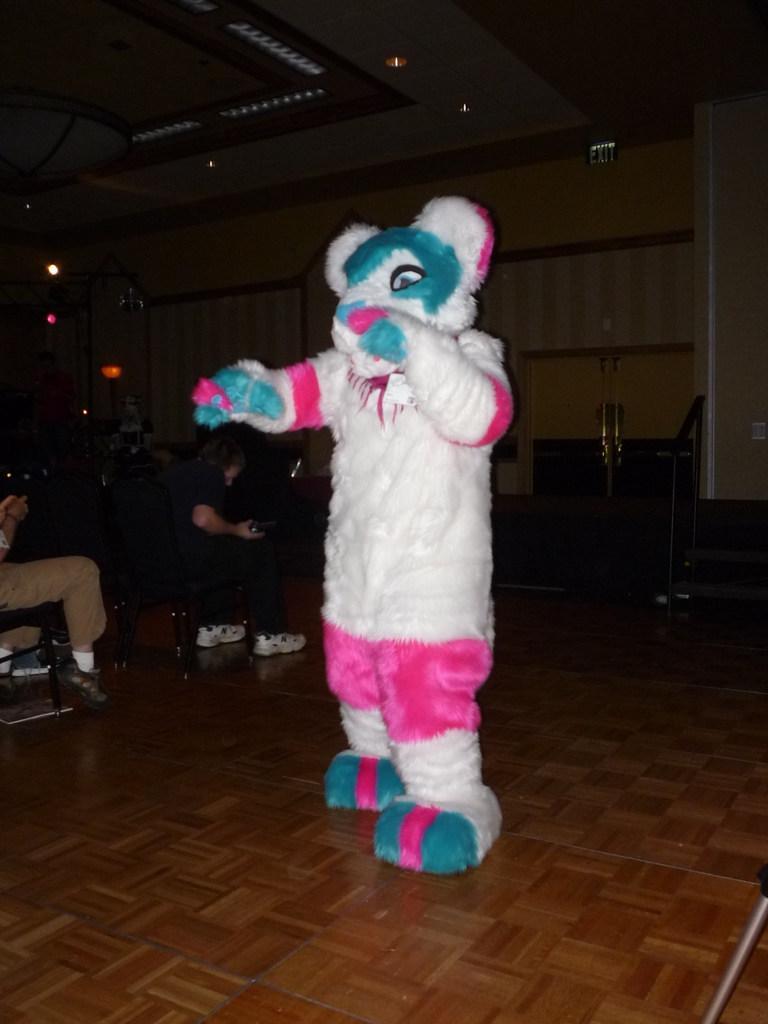Could you give a brief overview of what you see in this image? In the foreground I can see a person in a costume. In the background I can see a group of people are sitting on the chairs, tables, lights on a rooftop and a wall. This image is taken, may be in a hall. 